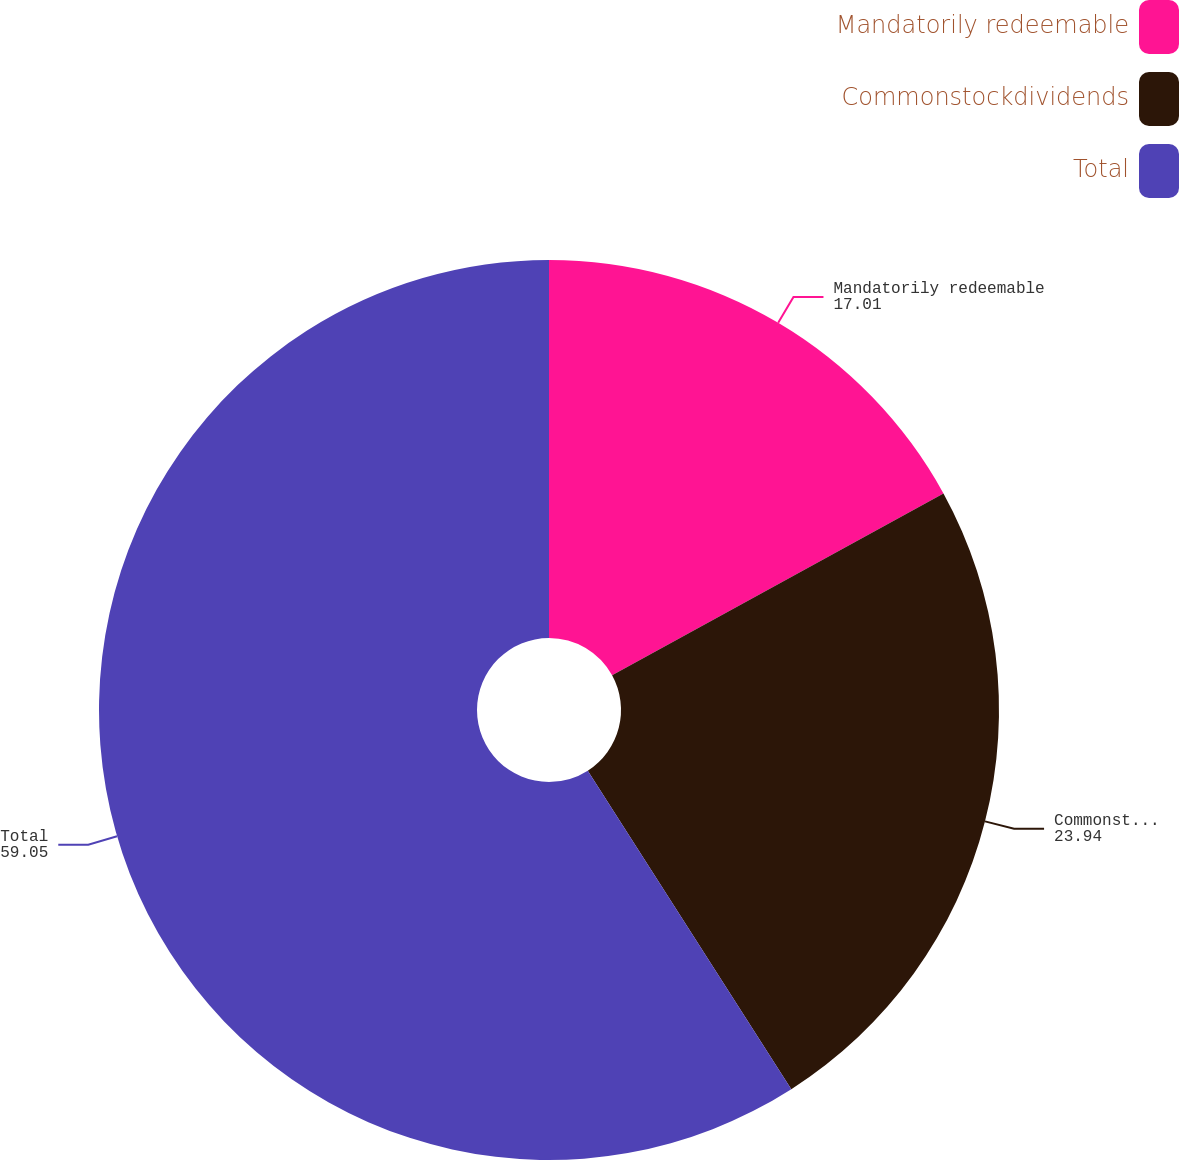Convert chart. <chart><loc_0><loc_0><loc_500><loc_500><pie_chart><fcel>Mandatorily redeemable<fcel>Commonstockdividends<fcel>Total<nl><fcel>17.01%<fcel>23.94%<fcel>59.05%<nl></chart> 